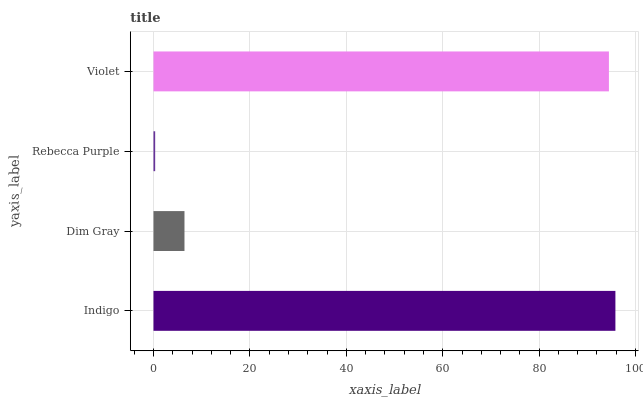Is Rebecca Purple the minimum?
Answer yes or no. Yes. Is Indigo the maximum?
Answer yes or no. Yes. Is Dim Gray the minimum?
Answer yes or no. No. Is Dim Gray the maximum?
Answer yes or no. No. Is Indigo greater than Dim Gray?
Answer yes or no. Yes. Is Dim Gray less than Indigo?
Answer yes or no. Yes. Is Dim Gray greater than Indigo?
Answer yes or no. No. Is Indigo less than Dim Gray?
Answer yes or no. No. Is Violet the high median?
Answer yes or no. Yes. Is Dim Gray the low median?
Answer yes or no. Yes. Is Indigo the high median?
Answer yes or no. No. Is Violet the low median?
Answer yes or no. No. 